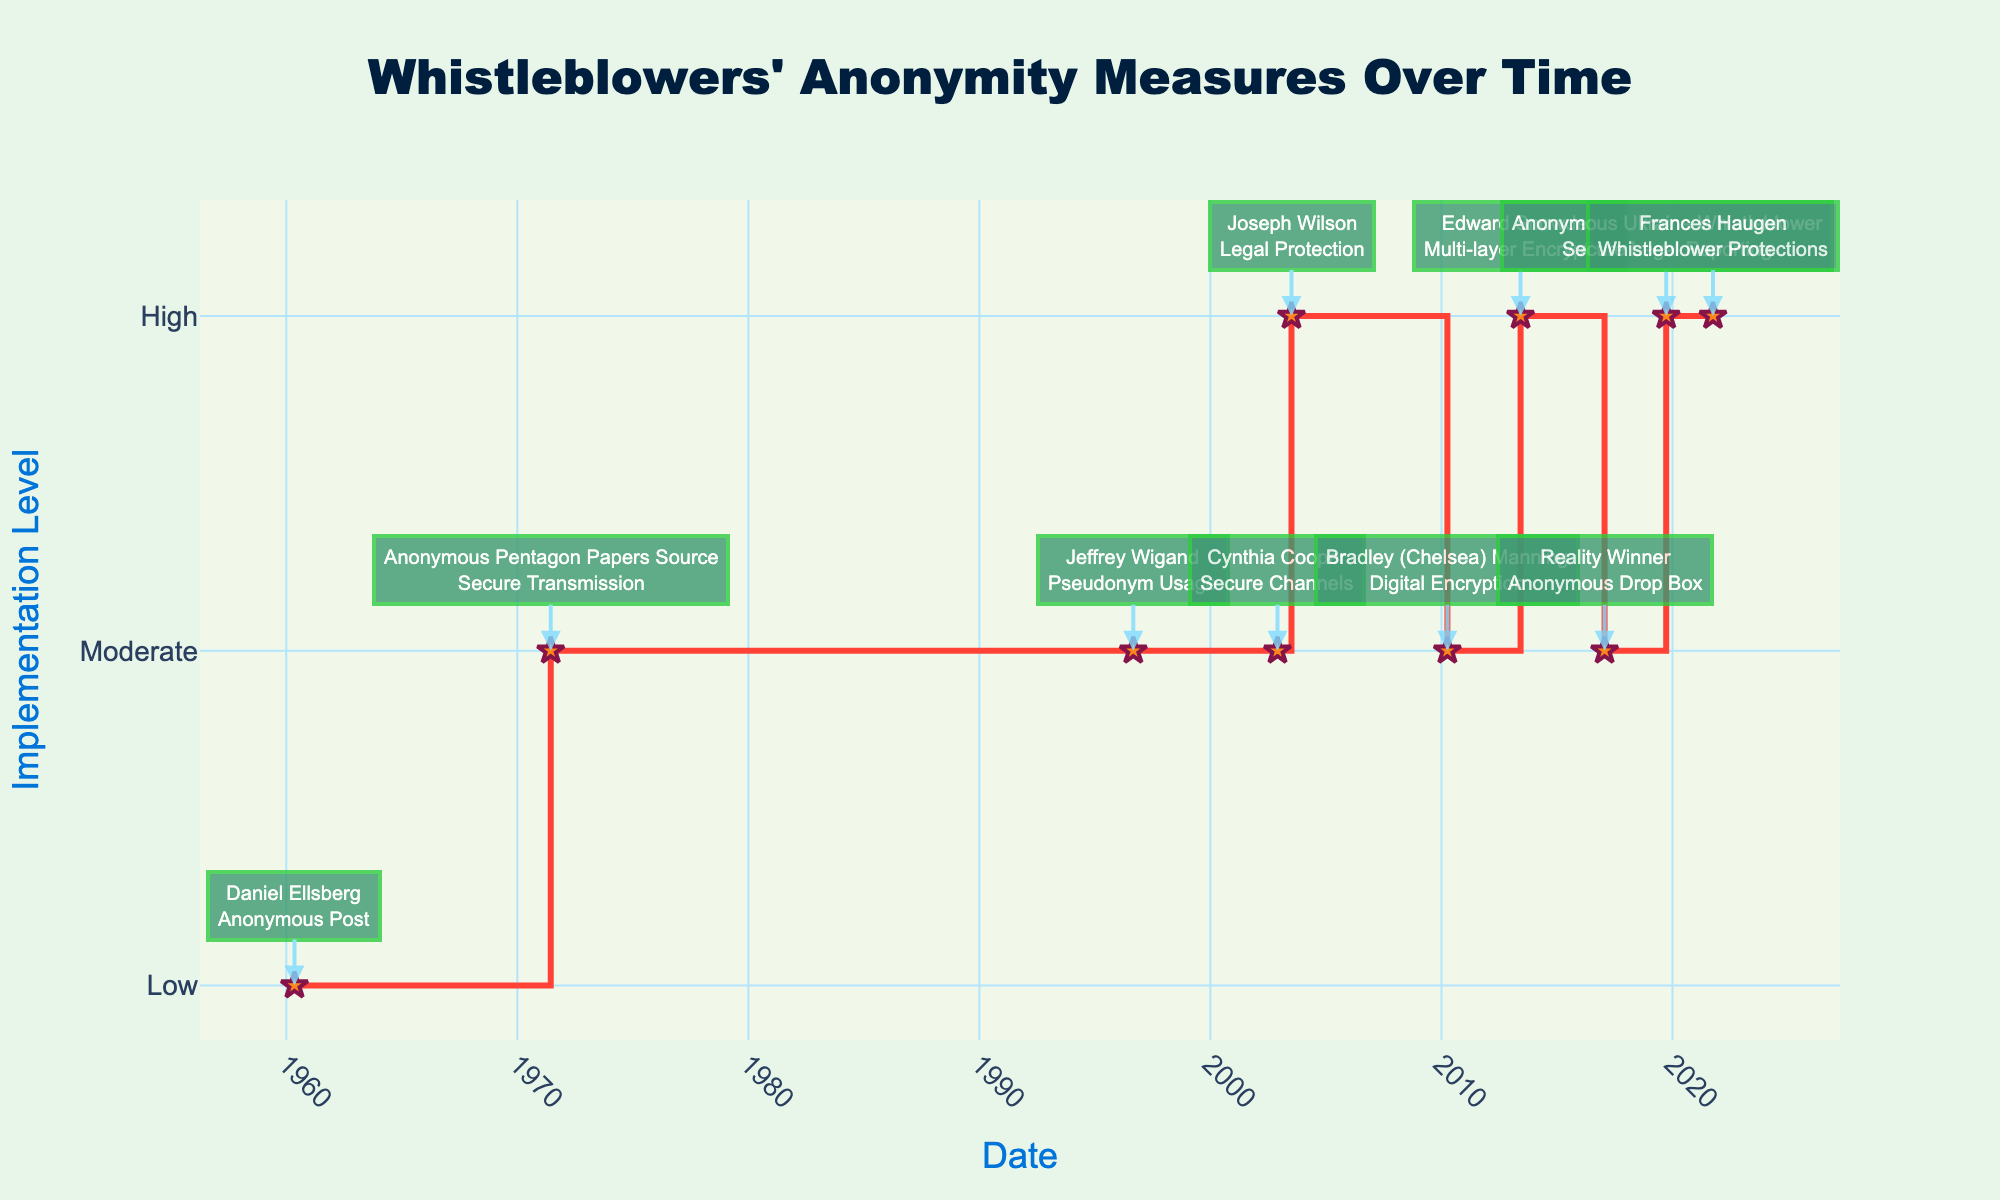When does the figure indicate that legal protections were first implemented for a whistleblower? The figure mentions Joseph Wilson on a specific date with an annotation for "Legal Protection". By examining the date for Joseph Wilson, we can identify when legal protections were first implemented.
Answer: 2003-07-06 What is the title of the figure? The title is prominently displayed at the top of the figure.
Answer: Whistleblowers’ Anonymity Measures Over Time Which whistleblower's anonymity measure had the highest implementation level on the earliest date? The figure shows both the anonymity measure and the implementation level for each date. The earliest date corresponds to Daniel Ellsberg, but the implementation level was low. The next check reveals Joseph Wilson in 2003 with a high level.
Answer: Joseph Wilson How many whistleblowers had anonymity measures implemented at a high level? The figure assigns numerical values to the implementation levels, and several points are plotted at the highest level (High corresponds to 3). Count these points.
Answer: 4 What type of anonymity measure was used by Edward Snowden? The figure includes annotations for each whistleblower that mention the type of anonymity measure. By finding Edward Snowden's point, the annotation reveals the required information.
Answer: Multi-layer Encryption Compare the implementation levels of anonymity measures between Reality Winner and Frances Haugen. The annotations and plotted points reveal Reality Winner with one level and Frances Haugen with another. Both are on different dates with their respective levels.
Answer: Both were Moderate and High Which years did the figure show a moderate implementation level for any whistleblower? The dates and corresponding points reveal which years have a moderate level (2). Locate the moderate points and extract the years.
Answer: 1971, 1996, 2002, 2010, 2017 What trend, if any, can be observed in the implementation levels of anonymity measures over time? Observe the plotted line and annotations, noting whether implementation levels increase, decrease, or remain constant over the years.
Answer: Increasing over time Which whistleblower had their anonymity measure documented at the highest implementation level in 2019? Examination of the annotations and date corresponding to 2019 will reveal the whistleblower with the highest level (High corresponds to 3).
Answer: Anonymous Ukraine Whistleblower What was the most common implementation level throughout the entire period? Count instances of each implementation level among the data points to determine the most frequent.
Answer: Moderate 